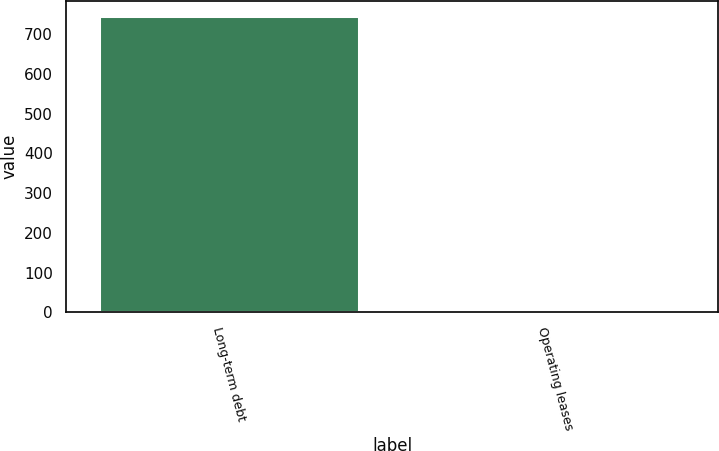<chart> <loc_0><loc_0><loc_500><loc_500><bar_chart><fcel>Long-term debt<fcel>Operating leases<nl><fcel>747<fcel>9<nl></chart> 